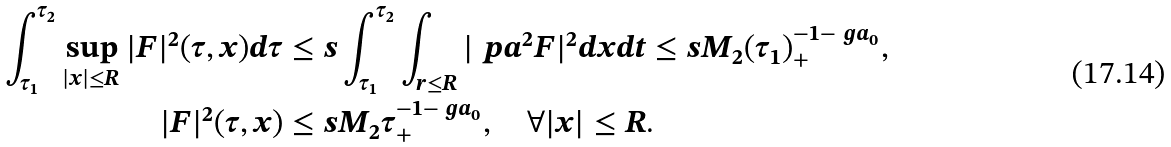Convert formula to latex. <formula><loc_0><loc_0><loc_500><loc_500>\int _ { \tau _ { 1 } } ^ { \tau _ { 2 } } \sup _ { | x | \leq R } | F | ^ { 2 } ( \tau , x ) d \tau & \leq s \int _ { \tau _ { 1 } } ^ { \tau _ { 2 } } \int _ { r \leq R } | \ p a ^ { 2 } F | ^ { 2 } d x d t \leq s M _ { 2 } ( \tau _ { 1 } ) _ { + } ^ { - 1 - \ g a _ { 0 } } , \\ | F | ^ { 2 } ( \tau , x ) & \leq s M _ { 2 } \tau _ { + } ^ { - 1 - \ g a _ { 0 } } , \quad \forall | x | \leq R .</formula> 